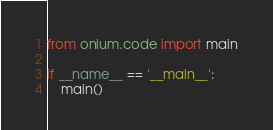<code> <loc_0><loc_0><loc_500><loc_500><_Python_>from onium.code import main

if __name__ == '__main__':
    main()
</code> 